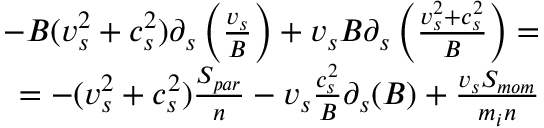Convert formula to latex. <formula><loc_0><loc_0><loc_500><loc_500>\begin{array} { r } { - B ( v _ { s } ^ { 2 } + c _ { s } ^ { 2 } ) \partial _ { s } \left ( \frac { v _ { s } } { B } \right ) + v _ { s } B \partial _ { s } \left ( \frac { v _ { s } ^ { 2 } + c _ { s } ^ { 2 } } { B } \right ) = } \\ { = - ( v _ { s } ^ { 2 } + c _ { s } ^ { 2 } ) \frac { S _ { p a r } } { n } - v _ { s } \frac { c _ { s } ^ { 2 } } { B } \partial _ { s } ( B ) + \frac { v _ { s } S _ { m o m } } { m _ { i } n } } \end{array}</formula> 